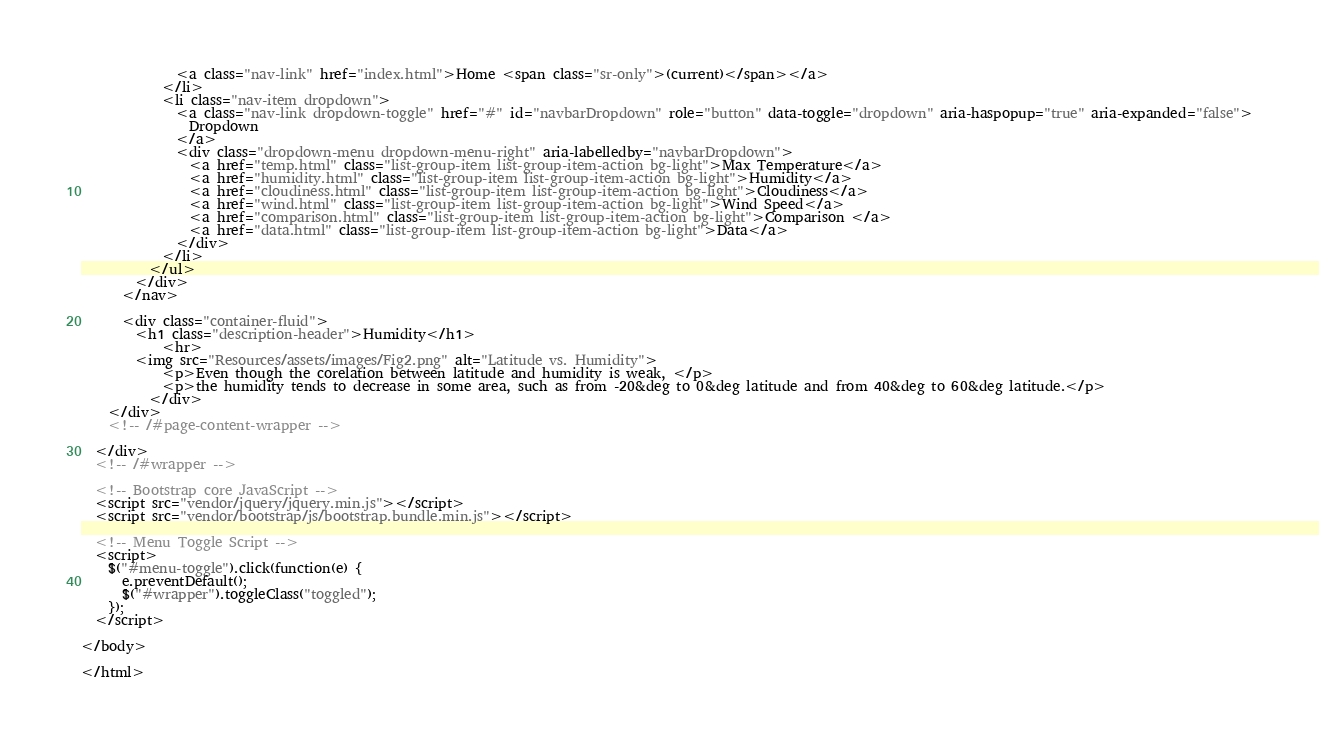Convert code to text. <code><loc_0><loc_0><loc_500><loc_500><_HTML_>              <a class="nav-link" href="index.html">Home <span class="sr-only">(current)</span></a>
            </li>
            <li class="nav-item dropdown">
              <a class="nav-link dropdown-toggle" href="#" id="navbarDropdown" role="button" data-toggle="dropdown" aria-haspopup="true" aria-expanded="false">
                Dropdown
              </a>
              <div class="dropdown-menu dropdown-menu-right" aria-labelledby="navbarDropdown">
                <a href="temp.html" class="list-group-item list-group-item-action bg-light">Max Temperature</a>
                <a href="humidity.html" class="list-group-item list-group-item-action bg-light">Humidity</a>
                <a href="cloudiness.html" class="list-group-item list-group-item-action bg-light">Cloudiness</a>
                <a href="wind.html" class="list-group-item list-group-item-action bg-light">Wind Speed</a>
                <a href="comparison.html" class="list-group-item list-group-item-action bg-light">Comparison </a>
                <a href="data.html" class="list-group-item list-group-item-action bg-light">Data</a>
              </div>
            </li>
          </ul>
        </div>
      </nav>

      <div class="container-fluid">
        <h1 class="description-header">Humidity</h1>
            <hr>
        <img src="Resources/assets/images/Fig2.png" alt="Latitude vs. Humidity">
            <p>Even though the corelation between latitude and humidity is weak, </p>
            <p>the humidity tends to decrease in some area, such as from -20&deg to 0&deg latitude and from 40&deg to 60&deg latitude.</p>
          </div>
    </div>
    <!-- /#page-content-wrapper -->

  </div>
  <!-- /#wrapper -->

  <!-- Bootstrap core JavaScript -->
  <script src="vendor/jquery/jquery.min.js"></script>
  <script src="vendor/bootstrap/js/bootstrap.bundle.min.js"></script>

  <!-- Menu Toggle Script -->
  <script>
    $("#menu-toggle").click(function(e) {
      e.preventDefault();
      $("#wrapper").toggleClass("toggled");
    });
  </script>

</body>

</html>
</code> 